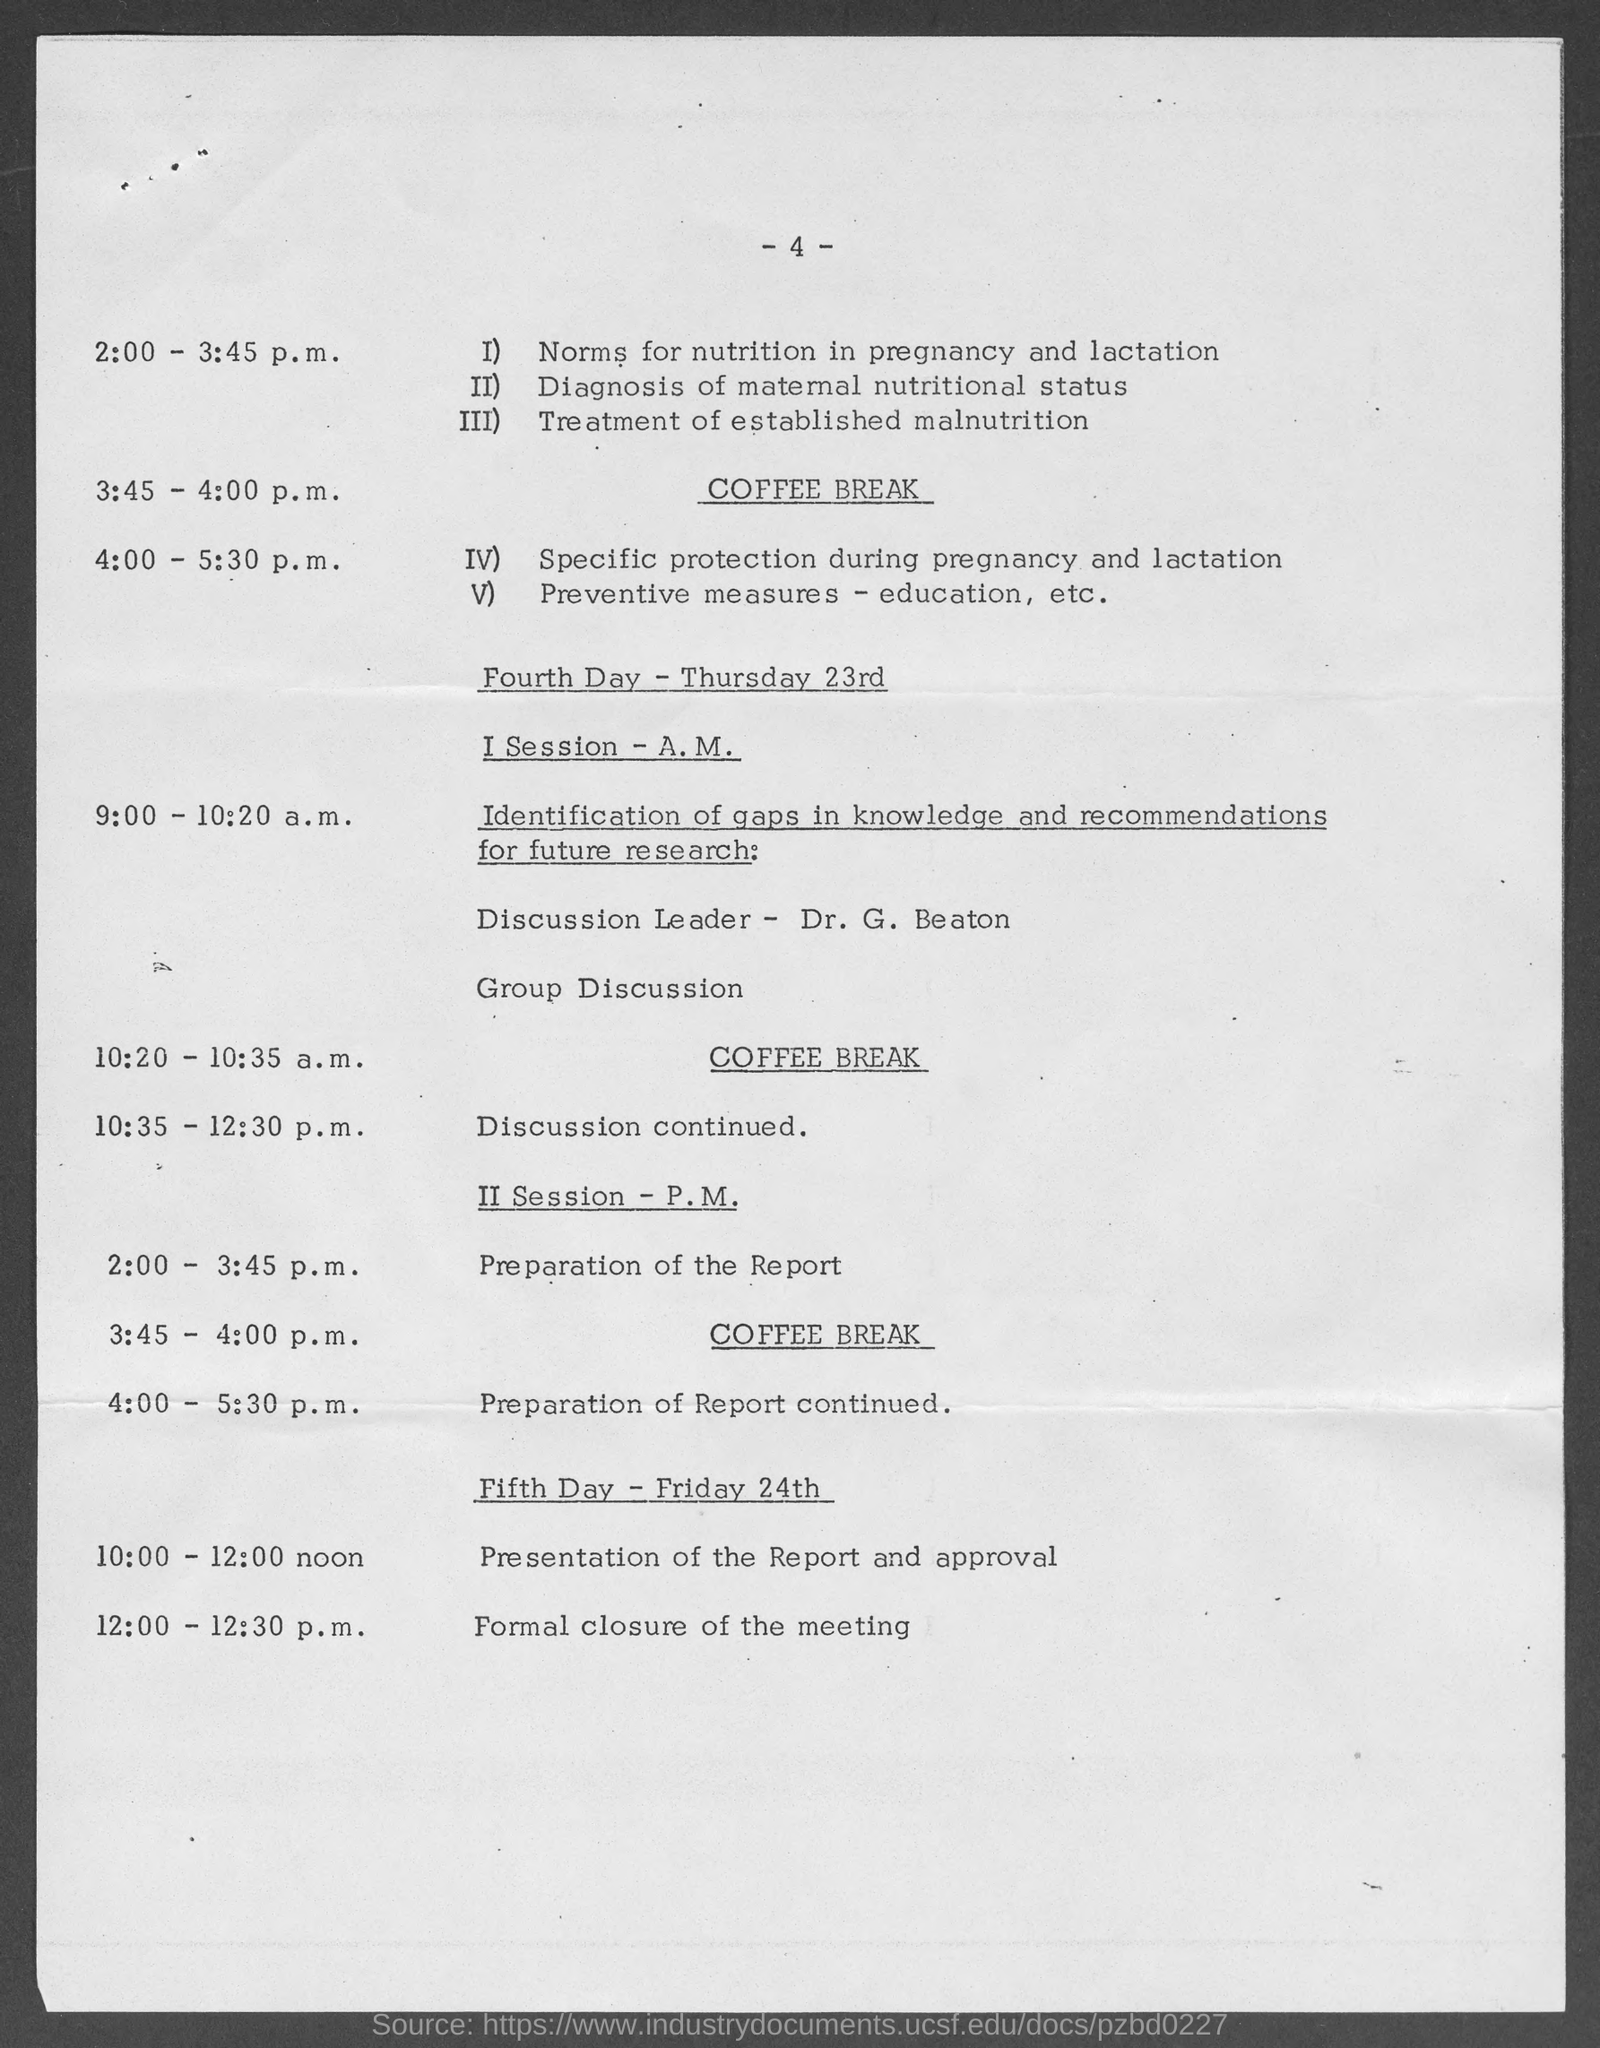Outline some significant characteristics in this image. The page number is -4-. 